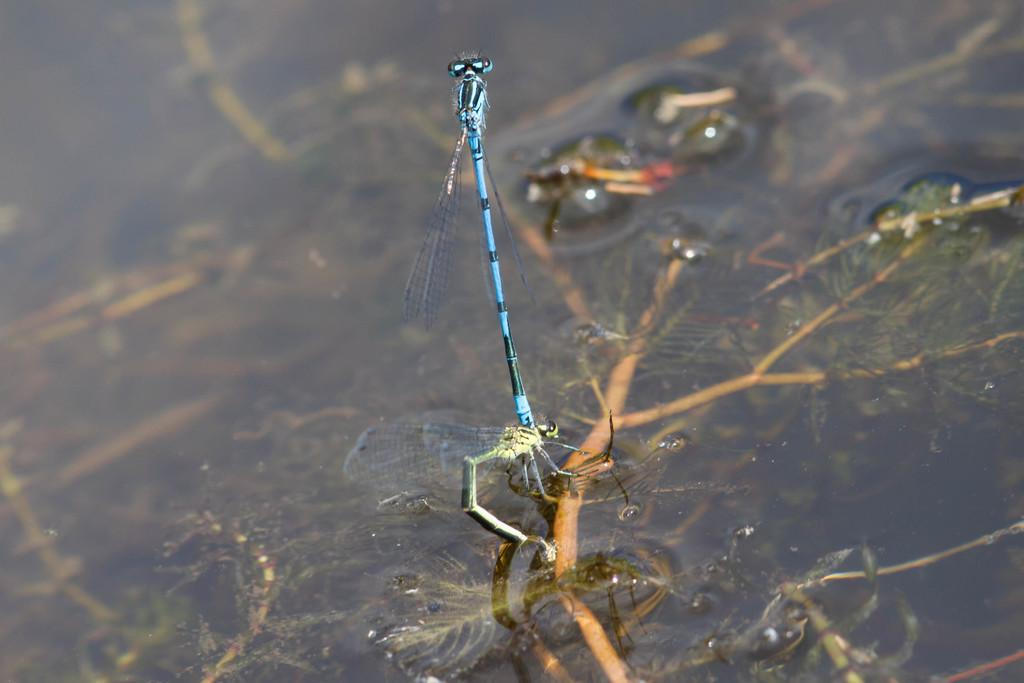What type of creatures can be seen in the image? There are insects in the image. What natural element is visible in the image? There is water visible in the image. What type of plant structures are present in the image? There are branches and leaves in the image. What type of fowl can be seen swimming in the water in the image? There are no fowl present in the image; it only features insects, water, branches, and leaves. 